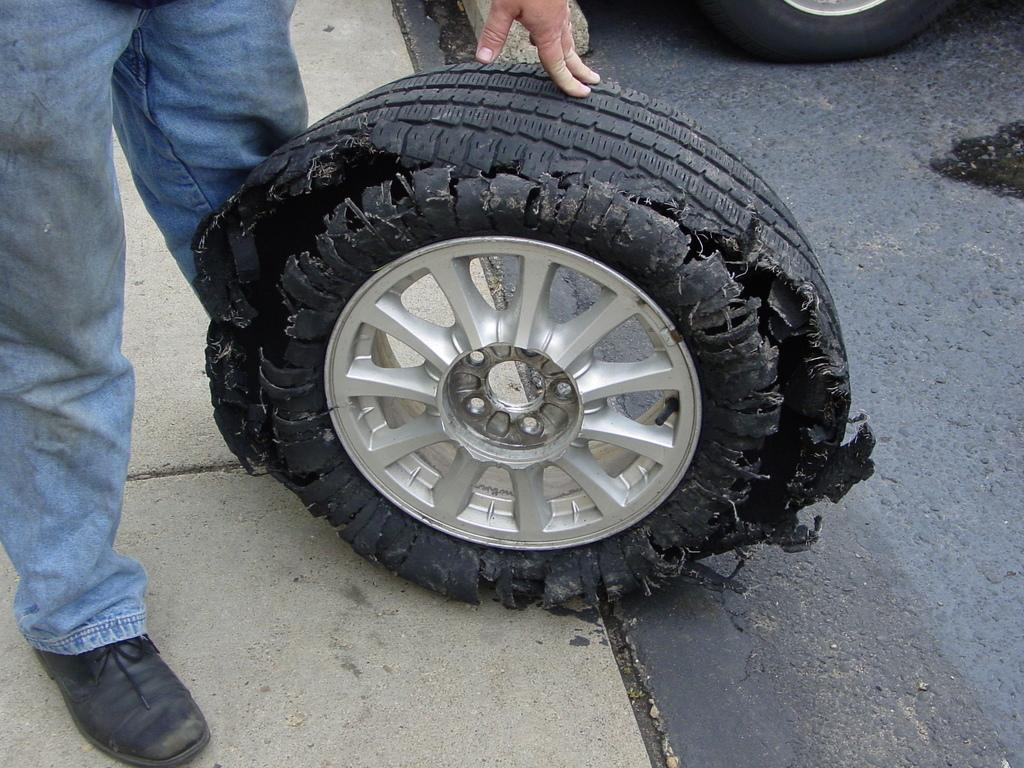Who or what is present in the image? There is a person in the image. How does the person in the image appear? The person appears to be tired. What else can be seen in the image besides the person? There are vehicles in the image. What is the surface that the person and vehicles are on? The ground is visible in the image. Can you see a squirrel wearing a coat in the image? There is no squirrel or coat present in the image. What type of snake is slithering across the ground in the image? There is no snake present in the image; only a person, vehicles, and the ground are visible. 